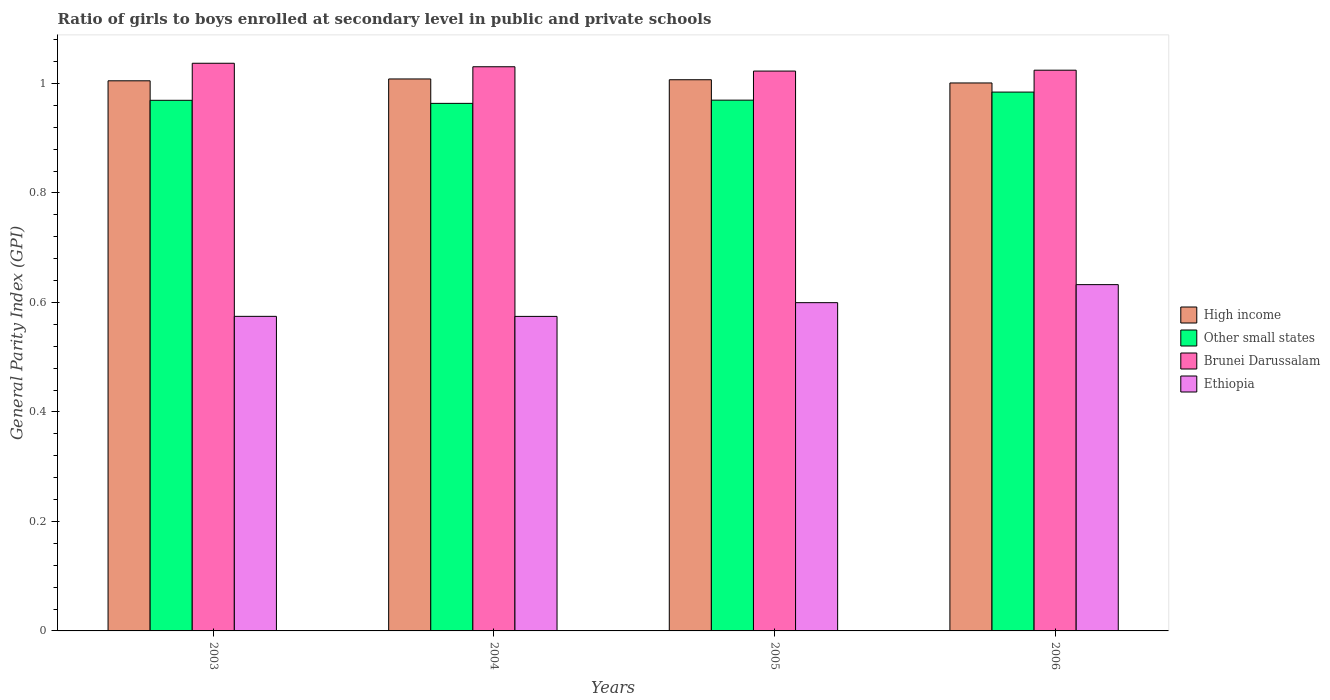How many different coloured bars are there?
Give a very brief answer. 4. How many groups of bars are there?
Offer a very short reply. 4. Are the number of bars per tick equal to the number of legend labels?
Make the answer very short. Yes. How many bars are there on the 1st tick from the right?
Your answer should be very brief. 4. What is the label of the 4th group of bars from the left?
Ensure brevity in your answer.  2006. What is the general parity index in High income in 2004?
Provide a succinct answer. 1.01. Across all years, what is the maximum general parity index in Brunei Darussalam?
Ensure brevity in your answer.  1.04. Across all years, what is the minimum general parity index in Brunei Darussalam?
Your answer should be very brief. 1.02. What is the total general parity index in Ethiopia in the graph?
Provide a short and direct response. 2.38. What is the difference between the general parity index in Other small states in 2004 and that in 2005?
Your response must be concise. -0.01. What is the difference between the general parity index in Other small states in 2005 and the general parity index in High income in 2004?
Give a very brief answer. -0.04. What is the average general parity index in Brunei Darussalam per year?
Provide a succinct answer. 1.03. In the year 2003, what is the difference between the general parity index in Other small states and general parity index in Brunei Darussalam?
Offer a terse response. -0.07. In how many years, is the general parity index in Brunei Darussalam greater than 1.04?
Keep it short and to the point. 0. What is the ratio of the general parity index in Ethiopia in 2004 to that in 2006?
Provide a short and direct response. 0.91. Is the difference between the general parity index in Other small states in 2003 and 2004 greater than the difference between the general parity index in Brunei Darussalam in 2003 and 2004?
Provide a succinct answer. No. What is the difference between the highest and the second highest general parity index in Other small states?
Provide a short and direct response. 0.01. What is the difference between the highest and the lowest general parity index in Other small states?
Make the answer very short. 0.02. What does the 3rd bar from the left in 2006 represents?
Ensure brevity in your answer.  Brunei Darussalam. What does the 2nd bar from the right in 2003 represents?
Make the answer very short. Brunei Darussalam. How many bars are there?
Make the answer very short. 16. How many years are there in the graph?
Provide a short and direct response. 4. What is the difference between two consecutive major ticks on the Y-axis?
Offer a terse response. 0.2. Does the graph contain any zero values?
Offer a very short reply. No. Does the graph contain grids?
Your answer should be compact. No. Where does the legend appear in the graph?
Make the answer very short. Center right. What is the title of the graph?
Keep it short and to the point. Ratio of girls to boys enrolled at secondary level in public and private schools. What is the label or title of the X-axis?
Your response must be concise. Years. What is the label or title of the Y-axis?
Your answer should be very brief. General Parity Index (GPI). What is the General Parity Index (GPI) of High income in 2003?
Give a very brief answer. 1. What is the General Parity Index (GPI) in Other small states in 2003?
Your answer should be compact. 0.97. What is the General Parity Index (GPI) of Brunei Darussalam in 2003?
Your answer should be very brief. 1.04. What is the General Parity Index (GPI) of Ethiopia in 2003?
Provide a succinct answer. 0.57. What is the General Parity Index (GPI) in High income in 2004?
Your answer should be very brief. 1.01. What is the General Parity Index (GPI) of Other small states in 2004?
Provide a succinct answer. 0.96. What is the General Parity Index (GPI) of Brunei Darussalam in 2004?
Your answer should be compact. 1.03. What is the General Parity Index (GPI) of Ethiopia in 2004?
Your answer should be very brief. 0.57. What is the General Parity Index (GPI) in High income in 2005?
Offer a terse response. 1.01. What is the General Parity Index (GPI) of Other small states in 2005?
Ensure brevity in your answer.  0.97. What is the General Parity Index (GPI) in Brunei Darussalam in 2005?
Your response must be concise. 1.02. What is the General Parity Index (GPI) in Ethiopia in 2005?
Ensure brevity in your answer.  0.6. What is the General Parity Index (GPI) in High income in 2006?
Ensure brevity in your answer.  1. What is the General Parity Index (GPI) of Other small states in 2006?
Your answer should be compact. 0.98. What is the General Parity Index (GPI) of Brunei Darussalam in 2006?
Give a very brief answer. 1.02. What is the General Parity Index (GPI) in Ethiopia in 2006?
Your response must be concise. 0.63. Across all years, what is the maximum General Parity Index (GPI) of High income?
Make the answer very short. 1.01. Across all years, what is the maximum General Parity Index (GPI) in Other small states?
Make the answer very short. 0.98. Across all years, what is the maximum General Parity Index (GPI) of Brunei Darussalam?
Offer a terse response. 1.04. Across all years, what is the maximum General Parity Index (GPI) in Ethiopia?
Your answer should be compact. 0.63. Across all years, what is the minimum General Parity Index (GPI) of High income?
Offer a terse response. 1. Across all years, what is the minimum General Parity Index (GPI) of Other small states?
Provide a short and direct response. 0.96. Across all years, what is the minimum General Parity Index (GPI) of Brunei Darussalam?
Your answer should be very brief. 1.02. Across all years, what is the minimum General Parity Index (GPI) of Ethiopia?
Provide a succinct answer. 0.57. What is the total General Parity Index (GPI) of High income in the graph?
Make the answer very short. 4.02. What is the total General Parity Index (GPI) of Other small states in the graph?
Your response must be concise. 3.89. What is the total General Parity Index (GPI) in Brunei Darussalam in the graph?
Your answer should be very brief. 4.11. What is the total General Parity Index (GPI) of Ethiopia in the graph?
Provide a short and direct response. 2.38. What is the difference between the General Parity Index (GPI) in High income in 2003 and that in 2004?
Make the answer very short. -0. What is the difference between the General Parity Index (GPI) in Other small states in 2003 and that in 2004?
Provide a succinct answer. 0.01. What is the difference between the General Parity Index (GPI) in Brunei Darussalam in 2003 and that in 2004?
Give a very brief answer. 0.01. What is the difference between the General Parity Index (GPI) in Ethiopia in 2003 and that in 2004?
Offer a terse response. 0. What is the difference between the General Parity Index (GPI) of High income in 2003 and that in 2005?
Keep it short and to the point. -0. What is the difference between the General Parity Index (GPI) in Other small states in 2003 and that in 2005?
Give a very brief answer. -0. What is the difference between the General Parity Index (GPI) of Brunei Darussalam in 2003 and that in 2005?
Provide a succinct answer. 0.01. What is the difference between the General Parity Index (GPI) in Ethiopia in 2003 and that in 2005?
Offer a very short reply. -0.03. What is the difference between the General Parity Index (GPI) in High income in 2003 and that in 2006?
Provide a short and direct response. 0. What is the difference between the General Parity Index (GPI) in Other small states in 2003 and that in 2006?
Your answer should be very brief. -0.01. What is the difference between the General Parity Index (GPI) of Brunei Darussalam in 2003 and that in 2006?
Your answer should be compact. 0.01. What is the difference between the General Parity Index (GPI) in Ethiopia in 2003 and that in 2006?
Your response must be concise. -0.06. What is the difference between the General Parity Index (GPI) of High income in 2004 and that in 2005?
Provide a short and direct response. 0. What is the difference between the General Parity Index (GPI) of Other small states in 2004 and that in 2005?
Your answer should be compact. -0.01. What is the difference between the General Parity Index (GPI) in Brunei Darussalam in 2004 and that in 2005?
Provide a short and direct response. 0.01. What is the difference between the General Parity Index (GPI) in Ethiopia in 2004 and that in 2005?
Your answer should be compact. -0.03. What is the difference between the General Parity Index (GPI) of High income in 2004 and that in 2006?
Make the answer very short. 0.01. What is the difference between the General Parity Index (GPI) of Other small states in 2004 and that in 2006?
Offer a very short reply. -0.02. What is the difference between the General Parity Index (GPI) in Brunei Darussalam in 2004 and that in 2006?
Provide a succinct answer. 0.01. What is the difference between the General Parity Index (GPI) of Ethiopia in 2004 and that in 2006?
Offer a very short reply. -0.06. What is the difference between the General Parity Index (GPI) in High income in 2005 and that in 2006?
Give a very brief answer. 0.01. What is the difference between the General Parity Index (GPI) in Other small states in 2005 and that in 2006?
Provide a short and direct response. -0.01. What is the difference between the General Parity Index (GPI) of Brunei Darussalam in 2005 and that in 2006?
Your answer should be compact. -0. What is the difference between the General Parity Index (GPI) of Ethiopia in 2005 and that in 2006?
Keep it short and to the point. -0.03. What is the difference between the General Parity Index (GPI) of High income in 2003 and the General Parity Index (GPI) of Other small states in 2004?
Offer a very short reply. 0.04. What is the difference between the General Parity Index (GPI) in High income in 2003 and the General Parity Index (GPI) in Brunei Darussalam in 2004?
Ensure brevity in your answer.  -0.03. What is the difference between the General Parity Index (GPI) of High income in 2003 and the General Parity Index (GPI) of Ethiopia in 2004?
Provide a succinct answer. 0.43. What is the difference between the General Parity Index (GPI) of Other small states in 2003 and the General Parity Index (GPI) of Brunei Darussalam in 2004?
Keep it short and to the point. -0.06. What is the difference between the General Parity Index (GPI) in Other small states in 2003 and the General Parity Index (GPI) in Ethiopia in 2004?
Give a very brief answer. 0.39. What is the difference between the General Parity Index (GPI) in Brunei Darussalam in 2003 and the General Parity Index (GPI) in Ethiopia in 2004?
Offer a very short reply. 0.46. What is the difference between the General Parity Index (GPI) in High income in 2003 and the General Parity Index (GPI) in Other small states in 2005?
Your answer should be very brief. 0.04. What is the difference between the General Parity Index (GPI) of High income in 2003 and the General Parity Index (GPI) of Brunei Darussalam in 2005?
Make the answer very short. -0.02. What is the difference between the General Parity Index (GPI) of High income in 2003 and the General Parity Index (GPI) of Ethiopia in 2005?
Your response must be concise. 0.41. What is the difference between the General Parity Index (GPI) of Other small states in 2003 and the General Parity Index (GPI) of Brunei Darussalam in 2005?
Give a very brief answer. -0.05. What is the difference between the General Parity Index (GPI) of Other small states in 2003 and the General Parity Index (GPI) of Ethiopia in 2005?
Offer a very short reply. 0.37. What is the difference between the General Parity Index (GPI) of Brunei Darussalam in 2003 and the General Parity Index (GPI) of Ethiopia in 2005?
Ensure brevity in your answer.  0.44. What is the difference between the General Parity Index (GPI) in High income in 2003 and the General Parity Index (GPI) in Other small states in 2006?
Offer a terse response. 0.02. What is the difference between the General Parity Index (GPI) in High income in 2003 and the General Parity Index (GPI) in Brunei Darussalam in 2006?
Provide a succinct answer. -0.02. What is the difference between the General Parity Index (GPI) in High income in 2003 and the General Parity Index (GPI) in Ethiopia in 2006?
Your response must be concise. 0.37. What is the difference between the General Parity Index (GPI) of Other small states in 2003 and the General Parity Index (GPI) of Brunei Darussalam in 2006?
Your response must be concise. -0.06. What is the difference between the General Parity Index (GPI) of Other small states in 2003 and the General Parity Index (GPI) of Ethiopia in 2006?
Keep it short and to the point. 0.34. What is the difference between the General Parity Index (GPI) of Brunei Darussalam in 2003 and the General Parity Index (GPI) of Ethiopia in 2006?
Keep it short and to the point. 0.4. What is the difference between the General Parity Index (GPI) in High income in 2004 and the General Parity Index (GPI) in Other small states in 2005?
Your answer should be very brief. 0.04. What is the difference between the General Parity Index (GPI) of High income in 2004 and the General Parity Index (GPI) of Brunei Darussalam in 2005?
Offer a very short reply. -0.01. What is the difference between the General Parity Index (GPI) in High income in 2004 and the General Parity Index (GPI) in Ethiopia in 2005?
Give a very brief answer. 0.41. What is the difference between the General Parity Index (GPI) in Other small states in 2004 and the General Parity Index (GPI) in Brunei Darussalam in 2005?
Give a very brief answer. -0.06. What is the difference between the General Parity Index (GPI) of Other small states in 2004 and the General Parity Index (GPI) of Ethiopia in 2005?
Ensure brevity in your answer.  0.36. What is the difference between the General Parity Index (GPI) in Brunei Darussalam in 2004 and the General Parity Index (GPI) in Ethiopia in 2005?
Provide a short and direct response. 0.43. What is the difference between the General Parity Index (GPI) in High income in 2004 and the General Parity Index (GPI) in Other small states in 2006?
Your response must be concise. 0.02. What is the difference between the General Parity Index (GPI) of High income in 2004 and the General Parity Index (GPI) of Brunei Darussalam in 2006?
Make the answer very short. -0.02. What is the difference between the General Parity Index (GPI) in High income in 2004 and the General Parity Index (GPI) in Ethiopia in 2006?
Make the answer very short. 0.38. What is the difference between the General Parity Index (GPI) of Other small states in 2004 and the General Parity Index (GPI) of Brunei Darussalam in 2006?
Provide a succinct answer. -0.06. What is the difference between the General Parity Index (GPI) in Other small states in 2004 and the General Parity Index (GPI) in Ethiopia in 2006?
Your response must be concise. 0.33. What is the difference between the General Parity Index (GPI) in Brunei Darussalam in 2004 and the General Parity Index (GPI) in Ethiopia in 2006?
Make the answer very short. 0.4. What is the difference between the General Parity Index (GPI) of High income in 2005 and the General Parity Index (GPI) of Other small states in 2006?
Offer a terse response. 0.02. What is the difference between the General Parity Index (GPI) in High income in 2005 and the General Parity Index (GPI) in Brunei Darussalam in 2006?
Your answer should be compact. -0.02. What is the difference between the General Parity Index (GPI) in High income in 2005 and the General Parity Index (GPI) in Ethiopia in 2006?
Your response must be concise. 0.37. What is the difference between the General Parity Index (GPI) of Other small states in 2005 and the General Parity Index (GPI) of Brunei Darussalam in 2006?
Your answer should be compact. -0.05. What is the difference between the General Parity Index (GPI) in Other small states in 2005 and the General Parity Index (GPI) in Ethiopia in 2006?
Provide a short and direct response. 0.34. What is the difference between the General Parity Index (GPI) of Brunei Darussalam in 2005 and the General Parity Index (GPI) of Ethiopia in 2006?
Offer a very short reply. 0.39. What is the average General Parity Index (GPI) in Other small states per year?
Keep it short and to the point. 0.97. What is the average General Parity Index (GPI) of Brunei Darussalam per year?
Offer a very short reply. 1.03. What is the average General Parity Index (GPI) in Ethiopia per year?
Your answer should be compact. 0.6. In the year 2003, what is the difference between the General Parity Index (GPI) of High income and General Parity Index (GPI) of Other small states?
Keep it short and to the point. 0.04. In the year 2003, what is the difference between the General Parity Index (GPI) of High income and General Parity Index (GPI) of Brunei Darussalam?
Ensure brevity in your answer.  -0.03. In the year 2003, what is the difference between the General Parity Index (GPI) of High income and General Parity Index (GPI) of Ethiopia?
Provide a succinct answer. 0.43. In the year 2003, what is the difference between the General Parity Index (GPI) of Other small states and General Parity Index (GPI) of Brunei Darussalam?
Offer a terse response. -0.07. In the year 2003, what is the difference between the General Parity Index (GPI) of Other small states and General Parity Index (GPI) of Ethiopia?
Ensure brevity in your answer.  0.39. In the year 2003, what is the difference between the General Parity Index (GPI) of Brunei Darussalam and General Parity Index (GPI) of Ethiopia?
Give a very brief answer. 0.46. In the year 2004, what is the difference between the General Parity Index (GPI) of High income and General Parity Index (GPI) of Other small states?
Your answer should be compact. 0.04. In the year 2004, what is the difference between the General Parity Index (GPI) in High income and General Parity Index (GPI) in Brunei Darussalam?
Offer a terse response. -0.02. In the year 2004, what is the difference between the General Parity Index (GPI) of High income and General Parity Index (GPI) of Ethiopia?
Keep it short and to the point. 0.43. In the year 2004, what is the difference between the General Parity Index (GPI) of Other small states and General Parity Index (GPI) of Brunei Darussalam?
Your response must be concise. -0.07. In the year 2004, what is the difference between the General Parity Index (GPI) of Other small states and General Parity Index (GPI) of Ethiopia?
Give a very brief answer. 0.39. In the year 2004, what is the difference between the General Parity Index (GPI) of Brunei Darussalam and General Parity Index (GPI) of Ethiopia?
Offer a very short reply. 0.46. In the year 2005, what is the difference between the General Parity Index (GPI) of High income and General Parity Index (GPI) of Other small states?
Keep it short and to the point. 0.04. In the year 2005, what is the difference between the General Parity Index (GPI) of High income and General Parity Index (GPI) of Brunei Darussalam?
Offer a terse response. -0.02. In the year 2005, what is the difference between the General Parity Index (GPI) of High income and General Parity Index (GPI) of Ethiopia?
Your answer should be very brief. 0.41. In the year 2005, what is the difference between the General Parity Index (GPI) in Other small states and General Parity Index (GPI) in Brunei Darussalam?
Offer a terse response. -0.05. In the year 2005, what is the difference between the General Parity Index (GPI) in Other small states and General Parity Index (GPI) in Ethiopia?
Provide a succinct answer. 0.37. In the year 2005, what is the difference between the General Parity Index (GPI) of Brunei Darussalam and General Parity Index (GPI) of Ethiopia?
Make the answer very short. 0.42. In the year 2006, what is the difference between the General Parity Index (GPI) in High income and General Parity Index (GPI) in Other small states?
Your answer should be compact. 0.02. In the year 2006, what is the difference between the General Parity Index (GPI) of High income and General Parity Index (GPI) of Brunei Darussalam?
Keep it short and to the point. -0.02. In the year 2006, what is the difference between the General Parity Index (GPI) in High income and General Parity Index (GPI) in Ethiopia?
Ensure brevity in your answer.  0.37. In the year 2006, what is the difference between the General Parity Index (GPI) in Other small states and General Parity Index (GPI) in Brunei Darussalam?
Give a very brief answer. -0.04. In the year 2006, what is the difference between the General Parity Index (GPI) in Other small states and General Parity Index (GPI) in Ethiopia?
Make the answer very short. 0.35. In the year 2006, what is the difference between the General Parity Index (GPI) of Brunei Darussalam and General Parity Index (GPI) of Ethiopia?
Provide a short and direct response. 0.39. What is the ratio of the General Parity Index (GPI) in Ethiopia in 2003 to that in 2004?
Make the answer very short. 1. What is the ratio of the General Parity Index (GPI) in High income in 2003 to that in 2005?
Your answer should be very brief. 1. What is the ratio of the General Parity Index (GPI) in Brunei Darussalam in 2003 to that in 2005?
Provide a short and direct response. 1.01. What is the ratio of the General Parity Index (GPI) of Other small states in 2003 to that in 2006?
Ensure brevity in your answer.  0.98. What is the ratio of the General Parity Index (GPI) in Brunei Darussalam in 2003 to that in 2006?
Provide a succinct answer. 1.01. What is the ratio of the General Parity Index (GPI) in Ethiopia in 2003 to that in 2006?
Your answer should be very brief. 0.91. What is the ratio of the General Parity Index (GPI) of High income in 2004 to that in 2005?
Provide a succinct answer. 1. What is the ratio of the General Parity Index (GPI) in Brunei Darussalam in 2004 to that in 2005?
Make the answer very short. 1.01. What is the ratio of the General Parity Index (GPI) in Ethiopia in 2004 to that in 2005?
Your answer should be very brief. 0.96. What is the ratio of the General Parity Index (GPI) of High income in 2004 to that in 2006?
Offer a terse response. 1.01. What is the ratio of the General Parity Index (GPI) in Other small states in 2004 to that in 2006?
Your answer should be compact. 0.98. What is the ratio of the General Parity Index (GPI) in Brunei Darussalam in 2004 to that in 2006?
Keep it short and to the point. 1.01. What is the ratio of the General Parity Index (GPI) in Ethiopia in 2004 to that in 2006?
Keep it short and to the point. 0.91. What is the ratio of the General Parity Index (GPI) of High income in 2005 to that in 2006?
Ensure brevity in your answer.  1.01. What is the ratio of the General Parity Index (GPI) of Other small states in 2005 to that in 2006?
Your answer should be very brief. 0.98. What is the ratio of the General Parity Index (GPI) of Brunei Darussalam in 2005 to that in 2006?
Offer a terse response. 1. What is the ratio of the General Parity Index (GPI) of Ethiopia in 2005 to that in 2006?
Offer a very short reply. 0.95. What is the difference between the highest and the second highest General Parity Index (GPI) in High income?
Ensure brevity in your answer.  0. What is the difference between the highest and the second highest General Parity Index (GPI) of Other small states?
Ensure brevity in your answer.  0.01. What is the difference between the highest and the second highest General Parity Index (GPI) in Brunei Darussalam?
Offer a terse response. 0.01. What is the difference between the highest and the second highest General Parity Index (GPI) of Ethiopia?
Your answer should be compact. 0.03. What is the difference between the highest and the lowest General Parity Index (GPI) of High income?
Make the answer very short. 0.01. What is the difference between the highest and the lowest General Parity Index (GPI) in Other small states?
Provide a succinct answer. 0.02. What is the difference between the highest and the lowest General Parity Index (GPI) in Brunei Darussalam?
Keep it short and to the point. 0.01. What is the difference between the highest and the lowest General Parity Index (GPI) of Ethiopia?
Give a very brief answer. 0.06. 